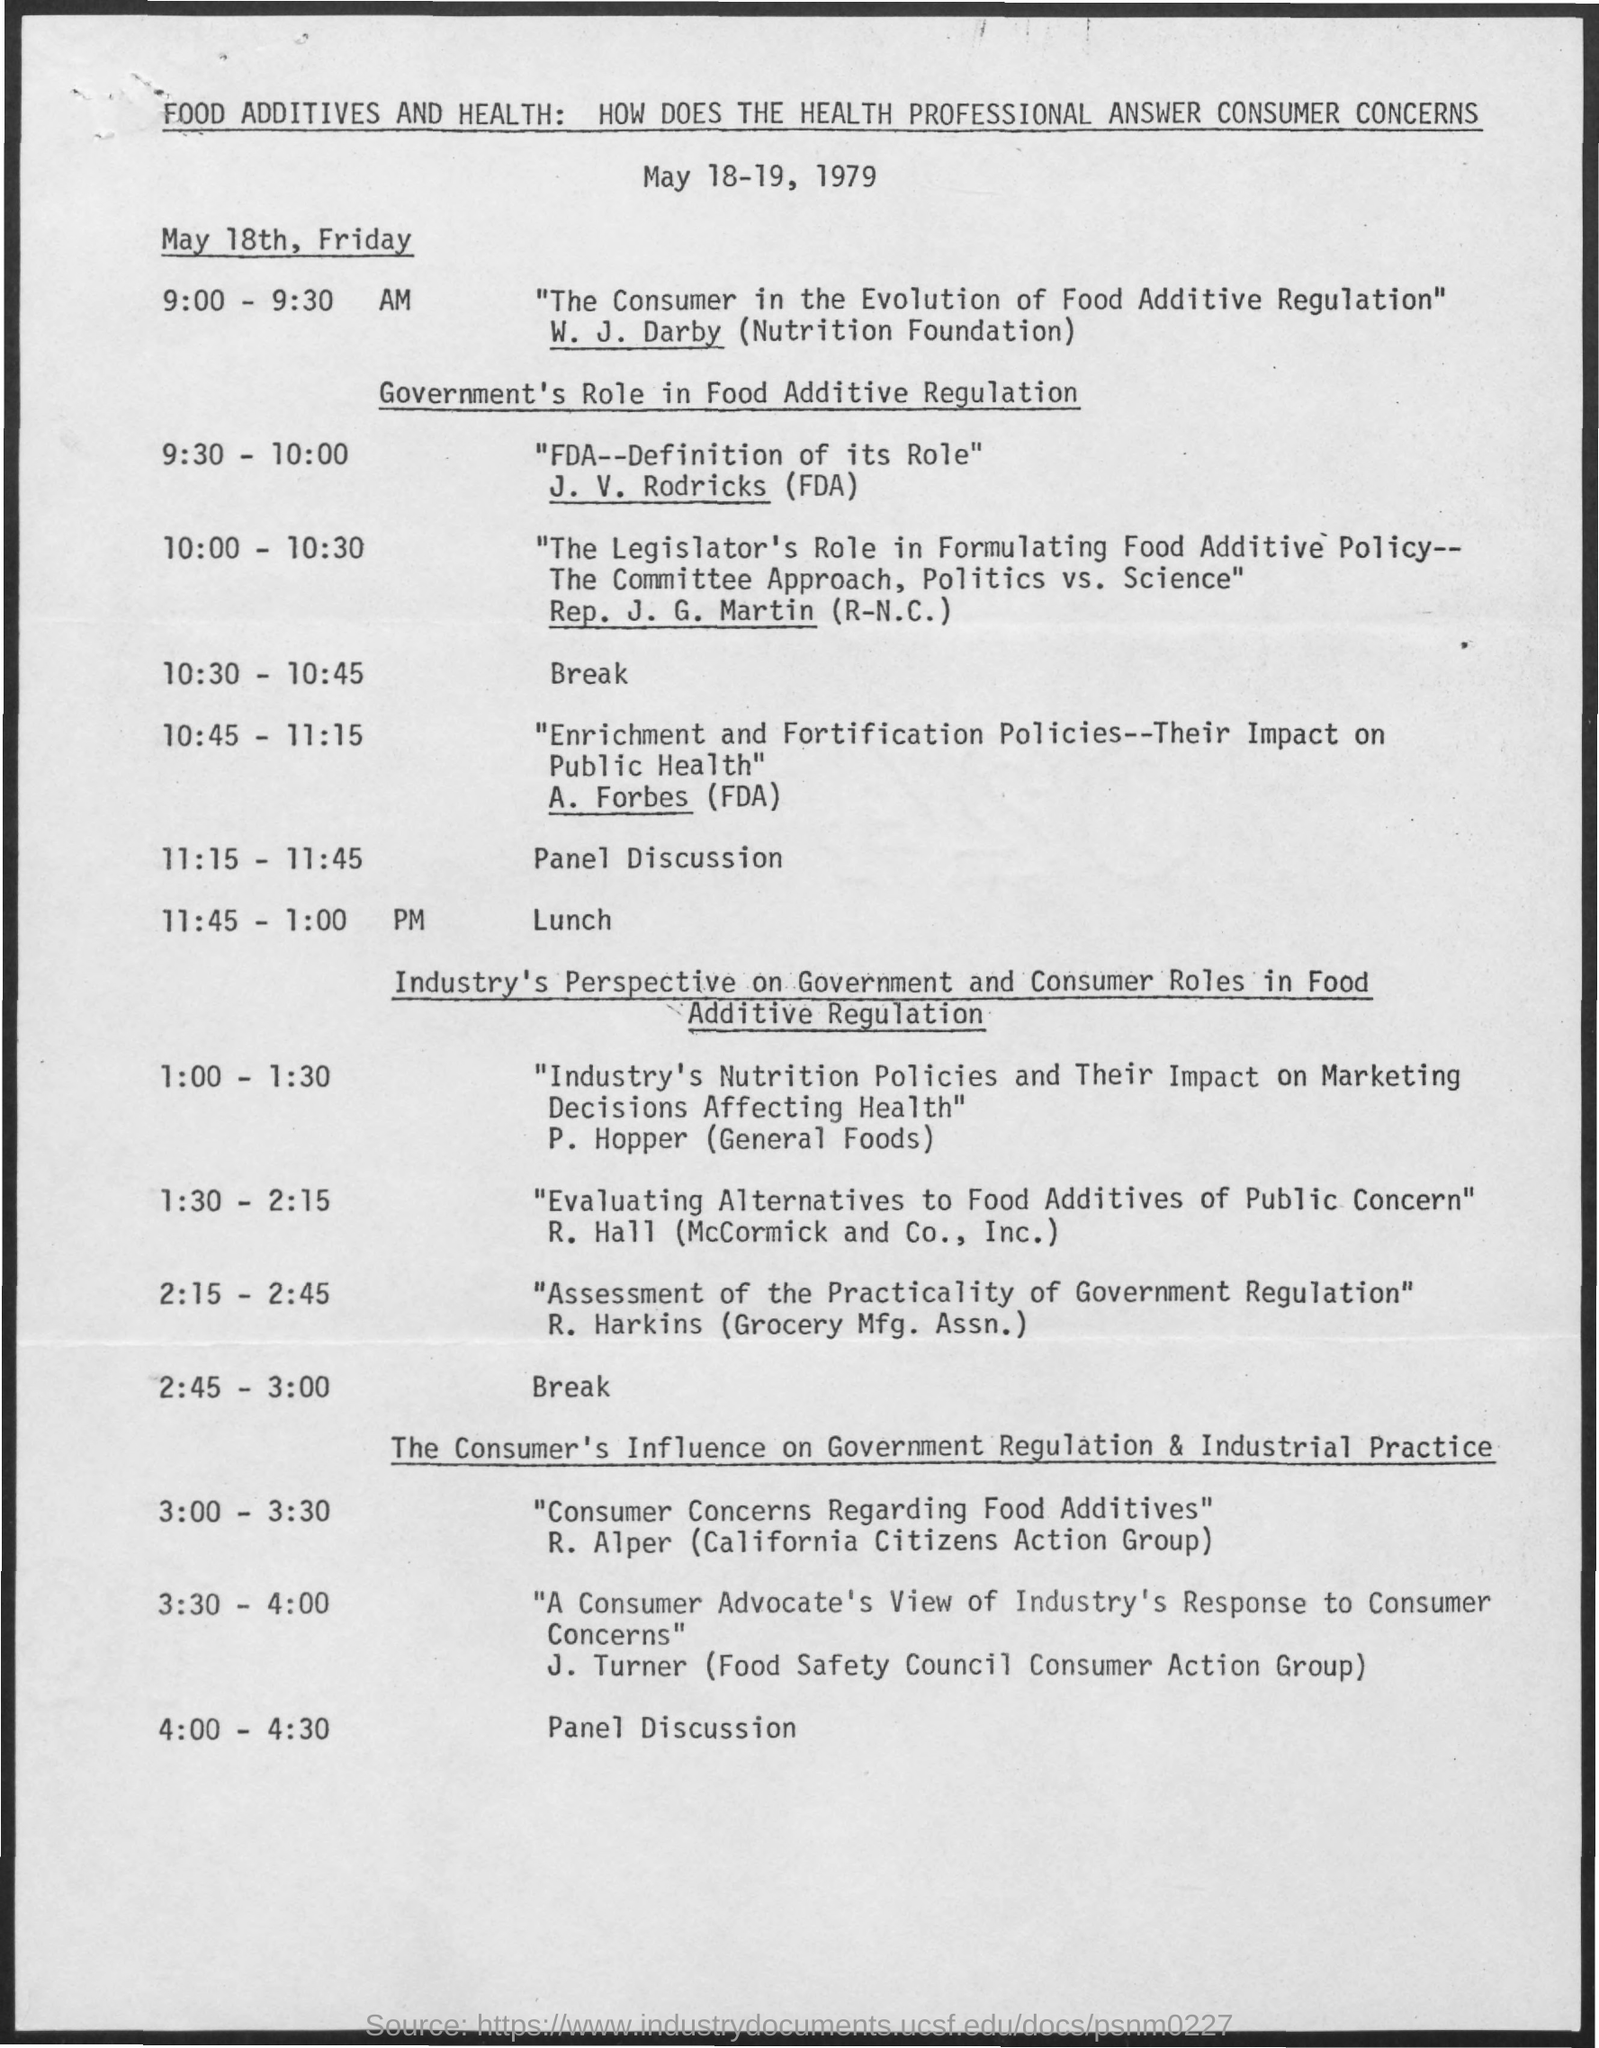Indicate a few pertinent items in this graphic. At 11:45 - 1:00 pm, it is lunch time. At the time of 11:15-11:45, there was a panel discussion taking place. At the time of 2:45 - 3:00, the schedule is as follows: a break will be taken. At 10:30 - 10:45, the schedule is as follows: a break. At the time of 4:00 - 4:30, a panel discussion will be taking place. 